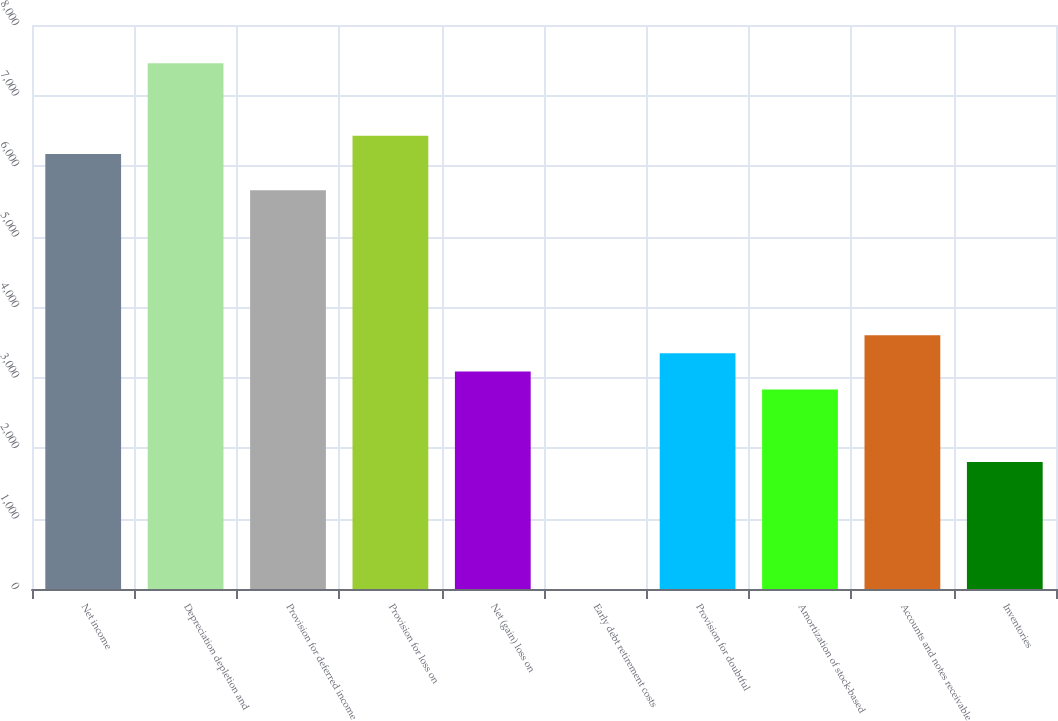<chart> <loc_0><loc_0><loc_500><loc_500><bar_chart><fcel>Net income<fcel>Depreciation depletion and<fcel>Provision for deferred income<fcel>Provision for loss on<fcel>Net (gain) loss on<fcel>Early debt retirement costs<fcel>Provision for doubtful<fcel>Amortization of stock-based<fcel>Accounts and notes receivable<fcel>Inventories<nl><fcel>6171.4<fcel>7456.9<fcel>5657.2<fcel>6428.5<fcel>3086.2<fcel>1<fcel>3343.3<fcel>2829.1<fcel>3600.4<fcel>1800.7<nl></chart> 